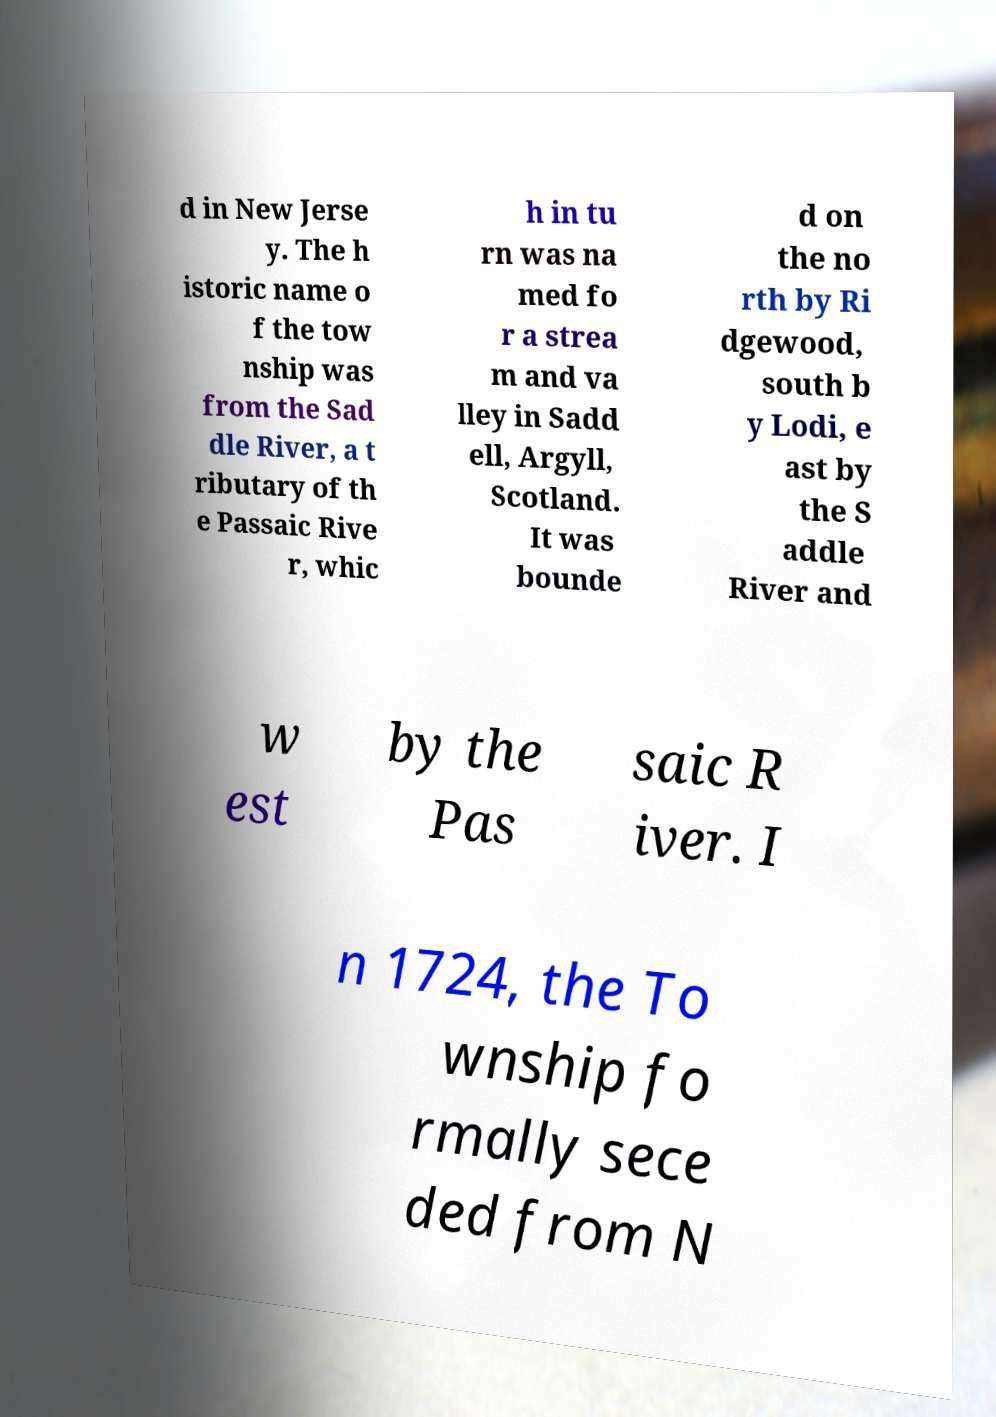Please identify and transcribe the text found in this image. d in New Jerse y. The h istoric name o f the tow nship was from the Sad dle River, a t ributary of th e Passaic Rive r, whic h in tu rn was na med fo r a strea m and va lley in Sadd ell, Argyll, Scotland. It was bounde d on the no rth by Ri dgewood, south b y Lodi, e ast by the S addle River and w est by the Pas saic R iver. I n 1724, the To wnship fo rmally sece ded from N 